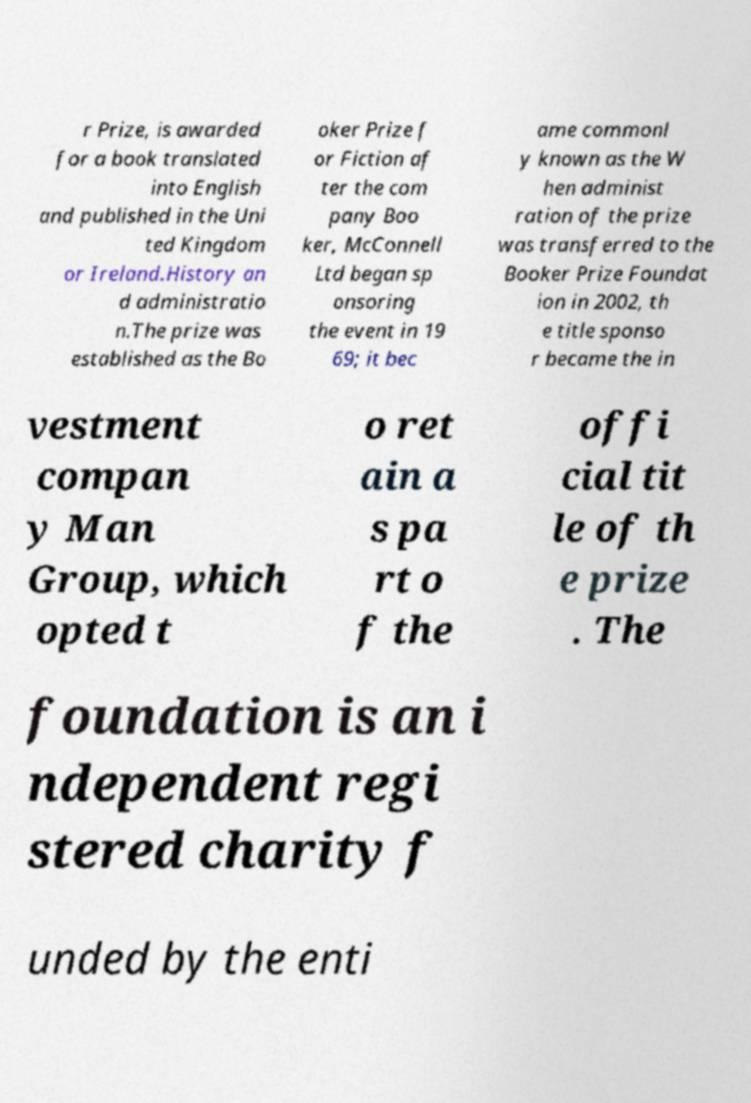Could you assist in decoding the text presented in this image and type it out clearly? r Prize, is awarded for a book translated into English and published in the Uni ted Kingdom or Ireland.History an d administratio n.The prize was established as the Bo oker Prize f or Fiction af ter the com pany Boo ker, McConnell Ltd began sp onsoring the event in 19 69; it bec ame commonl y known as the W hen administ ration of the prize was transferred to the Booker Prize Foundat ion in 2002, th e title sponso r became the in vestment compan y Man Group, which opted t o ret ain a s pa rt o f the offi cial tit le of th e prize . The foundation is an i ndependent regi stered charity f unded by the enti 